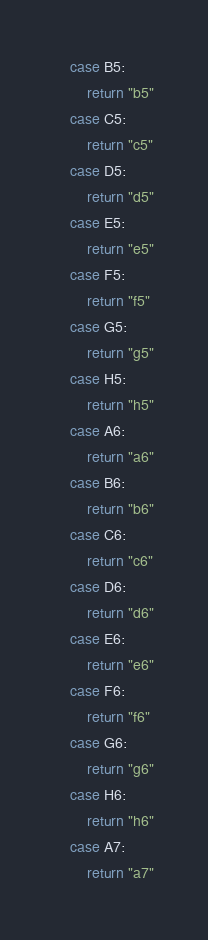<code> <loc_0><loc_0><loc_500><loc_500><_Go_>	case B5:
		return "b5"
	case C5:
		return "c5"
	case D5:
		return "d5"
	case E5:
		return "e5"
	case F5:
		return "f5"
	case G5:
		return "g5"
	case H5:
		return "h5"
	case A6:
		return "a6"
	case B6:
		return "b6"
	case C6:
		return "c6"
	case D6:
		return "d6"
	case E6:
		return "e6"
	case F6:
		return "f6"
	case G6:
		return "g6"
	case H6:
		return "h6"
	case A7:
		return "a7"</code> 